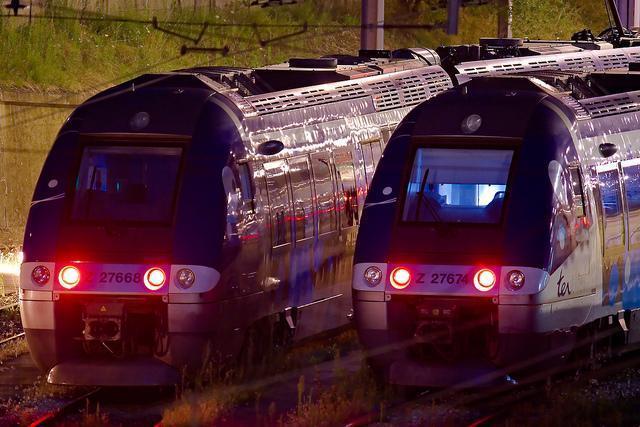How many trains are there?
Give a very brief answer. 2. How many people are in the boat?
Give a very brief answer. 0. 